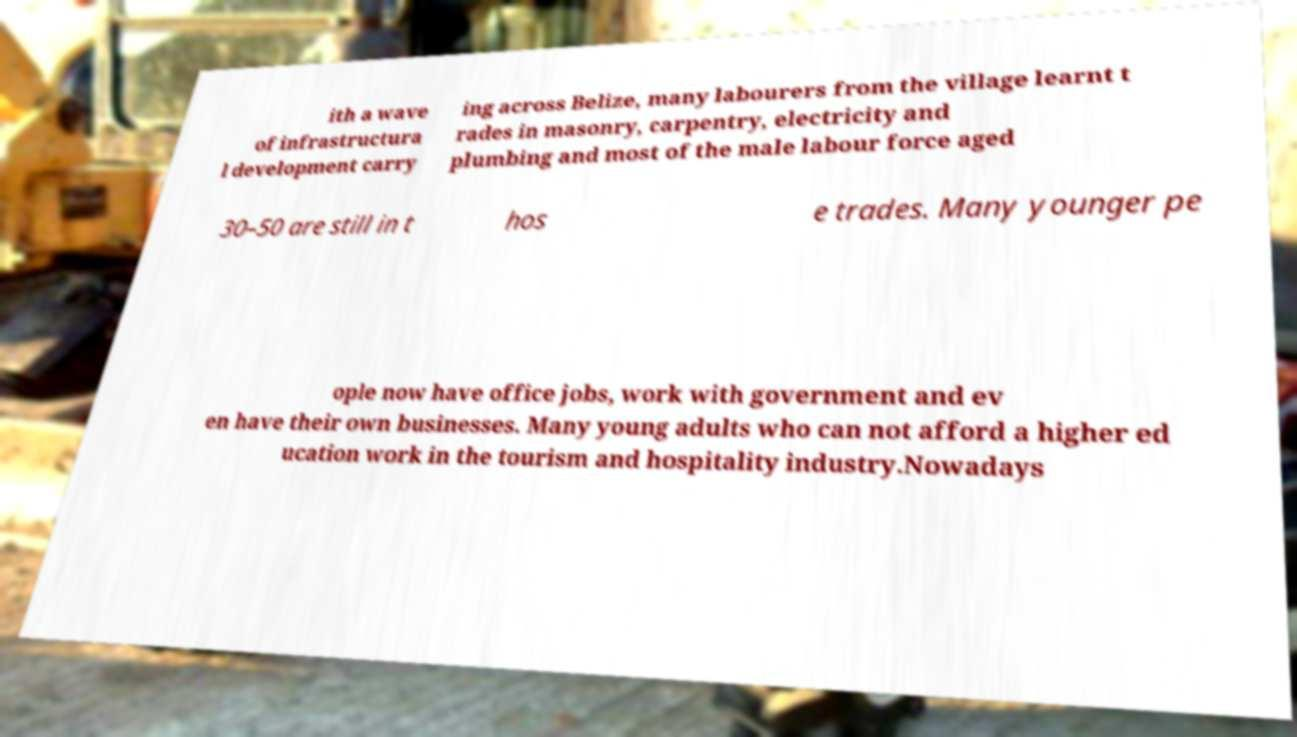Can you accurately transcribe the text from the provided image for me? ith a wave of infrastructura l development carry ing across Belize, many labourers from the village learnt t rades in masonry, carpentry, electricity and plumbing and most of the male labour force aged 30–50 are still in t hos e trades. Many younger pe ople now have office jobs, work with government and ev en have their own businesses. Many young adults who can not afford a higher ed ucation work in the tourism and hospitality industry.Nowadays 